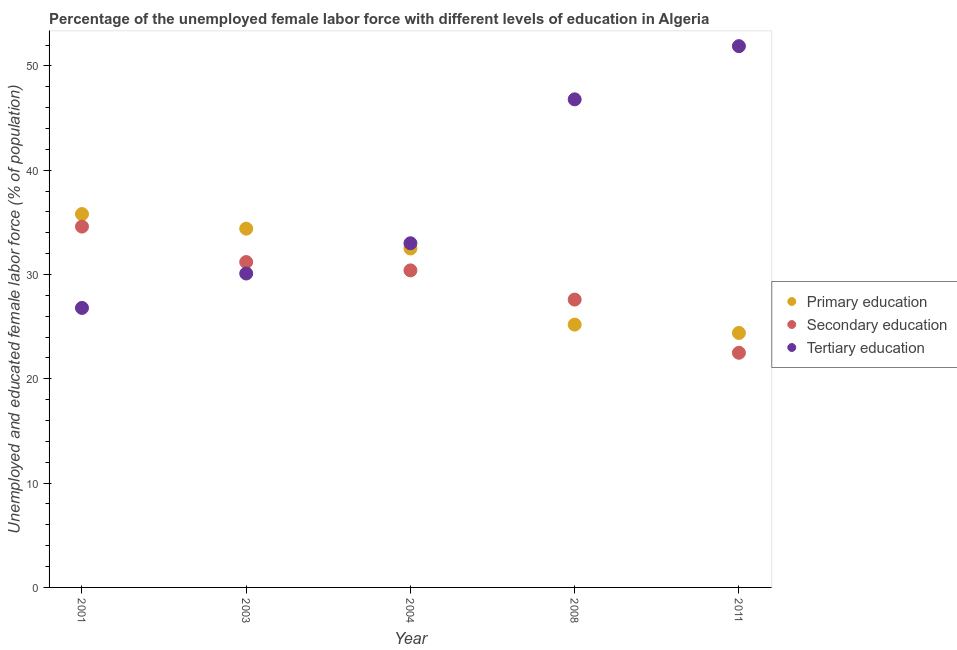How many different coloured dotlines are there?
Give a very brief answer. 3. Is the number of dotlines equal to the number of legend labels?
Your answer should be compact. Yes. What is the percentage of female labor force who received primary education in 2008?
Make the answer very short. 25.2. Across all years, what is the maximum percentage of female labor force who received primary education?
Ensure brevity in your answer.  35.8. Across all years, what is the minimum percentage of female labor force who received primary education?
Your response must be concise. 24.4. What is the total percentage of female labor force who received tertiary education in the graph?
Provide a short and direct response. 188.6. What is the difference between the percentage of female labor force who received tertiary education in 2004 and that in 2011?
Offer a terse response. -18.9. What is the difference between the percentage of female labor force who received tertiary education in 2003 and the percentage of female labor force who received secondary education in 2004?
Keep it short and to the point. -0.3. What is the average percentage of female labor force who received primary education per year?
Offer a very short reply. 30.46. In the year 2003, what is the difference between the percentage of female labor force who received primary education and percentage of female labor force who received tertiary education?
Offer a very short reply. 4.3. What is the ratio of the percentage of female labor force who received primary education in 2003 to that in 2011?
Your answer should be very brief. 1.41. What is the difference between the highest and the second highest percentage of female labor force who received tertiary education?
Keep it short and to the point. 5.1. What is the difference between the highest and the lowest percentage of female labor force who received primary education?
Give a very brief answer. 11.4. In how many years, is the percentage of female labor force who received tertiary education greater than the average percentage of female labor force who received tertiary education taken over all years?
Offer a terse response. 2. Does the percentage of female labor force who received primary education monotonically increase over the years?
Your answer should be compact. No. Is the percentage of female labor force who received primary education strictly less than the percentage of female labor force who received secondary education over the years?
Make the answer very short. No. What is the difference between two consecutive major ticks on the Y-axis?
Provide a short and direct response. 10. Are the values on the major ticks of Y-axis written in scientific E-notation?
Provide a short and direct response. No. Does the graph contain any zero values?
Ensure brevity in your answer.  No. Where does the legend appear in the graph?
Keep it short and to the point. Center right. How are the legend labels stacked?
Give a very brief answer. Vertical. What is the title of the graph?
Offer a very short reply. Percentage of the unemployed female labor force with different levels of education in Algeria. Does "Total employers" appear as one of the legend labels in the graph?
Ensure brevity in your answer.  No. What is the label or title of the X-axis?
Provide a short and direct response. Year. What is the label or title of the Y-axis?
Provide a short and direct response. Unemployed and educated female labor force (% of population). What is the Unemployed and educated female labor force (% of population) in Primary education in 2001?
Ensure brevity in your answer.  35.8. What is the Unemployed and educated female labor force (% of population) in Secondary education in 2001?
Give a very brief answer. 34.6. What is the Unemployed and educated female labor force (% of population) of Tertiary education in 2001?
Offer a very short reply. 26.8. What is the Unemployed and educated female labor force (% of population) of Primary education in 2003?
Provide a succinct answer. 34.4. What is the Unemployed and educated female labor force (% of population) in Secondary education in 2003?
Make the answer very short. 31.2. What is the Unemployed and educated female labor force (% of population) of Tertiary education in 2003?
Ensure brevity in your answer.  30.1. What is the Unemployed and educated female labor force (% of population) of Primary education in 2004?
Make the answer very short. 32.5. What is the Unemployed and educated female labor force (% of population) of Secondary education in 2004?
Offer a very short reply. 30.4. What is the Unemployed and educated female labor force (% of population) of Primary education in 2008?
Offer a very short reply. 25.2. What is the Unemployed and educated female labor force (% of population) of Secondary education in 2008?
Make the answer very short. 27.6. What is the Unemployed and educated female labor force (% of population) in Tertiary education in 2008?
Ensure brevity in your answer.  46.8. What is the Unemployed and educated female labor force (% of population) in Primary education in 2011?
Offer a terse response. 24.4. What is the Unemployed and educated female labor force (% of population) of Secondary education in 2011?
Offer a very short reply. 22.5. What is the Unemployed and educated female labor force (% of population) of Tertiary education in 2011?
Provide a succinct answer. 51.9. Across all years, what is the maximum Unemployed and educated female labor force (% of population) of Primary education?
Your answer should be very brief. 35.8. Across all years, what is the maximum Unemployed and educated female labor force (% of population) of Secondary education?
Your answer should be compact. 34.6. Across all years, what is the maximum Unemployed and educated female labor force (% of population) of Tertiary education?
Give a very brief answer. 51.9. Across all years, what is the minimum Unemployed and educated female labor force (% of population) in Primary education?
Your response must be concise. 24.4. Across all years, what is the minimum Unemployed and educated female labor force (% of population) in Tertiary education?
Your answer should be very brief. 26.8. What is the total Unemployed and educated female labor force (% of population) of Primary education in the graph?
Give a very brief answer. 152.3. What is the total Unemployed and educated female labor force (% of population) in Secondary education in the graph?
Offer a terse response. 146.3. What is the total Unemployed and educated female labor force (% of population) in Tertiary education in the graph?
Offer a terse response. 188.6. What is the difference between the Unemployed and educated female labor force (% of population) in Primary education in 2001 and that in 2003?
Offer a very short reply. 1.4. What is the difference between the Unemployed and educated female labor force (% of population) of Secondary education in 2001 and that in 2003?
Make the answer very short. 3.4. What is the difference between the Unemployed and educated female labor force (% of population) of Primary education in 2001 and that in 2004?
Your response must be concise. 3.3. What is the difference between the Unemployed and educated female labor force (% of population) of Tertiary education in 2001 and that in 2004?
Your response must be concise. -6.2. What is the difference between the Unemployed and educated female labor force (% of population) of Secondary education in 2001 and that in 2011?
Keep it short and to the point. 12.1. What is the difference between the Unemployed and educated female labor force (% of population) in Tertiary education in 2001 and that in 2011?
Make the answer very short. -25.1. What is the difference between the Unemployed and educated female labor force (% of population) in Primary education in 2003 and that in 2008?
Offer a terse response. 9.2. What is the difference between the Unemployed and educated female labor force (% of population) of Secondary education in 2003 and that in 2008?
Provide a short and direct response. 3.6. What is the difference between the Unemployed and educated female labor force (% of population) of Tertiary education in 2003 and that in 2008?
Give a very brief answer. -16.7. What is the difference between the Unemployed and educated female labor force (% of population) of Secondary education in 2003 and that in 2011?
Provide a succinct answer. 8.7. What is the difference between the Unemployed and educated female labor force (% of population) in Tertiary education in 2003 and that in 2011?
Provide a short and direct response. -21.8. What is the difference between the Unemployed and educated female labor force (% of population) of Secondary education in 2004 and that in 2008?
Your response must be concise. 2.8. What is the difference between the Unemployed and educated female labor force (% of population) of Primary education in 2004 and that in 2011?
Provide a succinct answer. 8.1. What is the difference between the Unemployed and educated female labor force (% of population) of Tertiary education in 2004 and that in 2011?
Offer a terse response. -18.9. What is the difference between the Unemployed and educated female labor force (% of population) in Secondary education in 2008 and that in 2011?
Your answer should be compact. 5.1. What is the difference between the Unemployed and educated female labor force (% of population) of Tertiary education in 2008 and that in 2011?
Your answer should be compact. -5.1. What is the difference between the Unemployed and educated female labor force (% of population) of Primary education in 2001 and the Unemployed and educated female labor force (% of population) of Secondary education in 2003?
Your response must be concise. 4.6. What is the difference between the Unemployed and educated female labor force (% of population) in Primary education in 2001 and the Unemployed and educated female labor force (% of population) in Tertiary education in 2003?
Make the answer very short. 5.7. What is the difference between the Unemployed and educated female labor force (% of population) of Primary education in 2001 and the Unemployed and educated female labor force (% of population) of Secondary education in 2004?
Make the answer very short. 5.4. What is the difference between the Unemployed and educated female labor force (% of population) in Primary education in 2001 and the Unemployed and educated female labor force (% of population) in Tertiary education in 2004?
Provide a short and direct response. 2.8. What is the difference between the Unemployed and educated female labor force (% of population) in Secondary education in 2001 and the Unemployed and educated female labor force (% of population) in Tertiary education in 2004?
Your answer should be very brief. 1.6. What is the difference between the Unemployed and educated female labor force (% of population) in Secondary education in 2001 and the Unemployed and educated female labor force (% of population) in Tertiary education in 2008?
Offer a terse response. -12.2. What is the difference between the Unemployed and educated female labor force (% of population) in Primary education in 2001 and the Unemployed and educated female labor force (% of population) in Secondary education in 2011?
Keep it short and to the point. 13.3. What is the difference between the Unemployed and educated female labor force (% of population) of Primary education in 2001 and the Unemployed and educated female labor force (% of population) of Tertiary education in 2011?
Your answer should be very brief. -16.1. What is the difference between the Unemployed and educated female labor force (% of population) of Secondary education in 2001 and the Unemployed and educated female labor force (% of population) of Tertiary education in 2011?
Provide a short and direct response. -17.3. What is the difference between the Unemployed and educated female labor force (% of population) of Secondary education in 2003 and the Unemployed and educated female labor force (% of population) of Tertiary education in 2004?
Offer a very short reply. -1.8. What is the difference between the Unemployed and educated female labor force (% of population) in Primary education in 2003 and the Unemployed and educated female labor force (% of population) in Tertiary education in 2008?
Make the answer very short. -12.4. What is the difference between the Unemployed and educated female labor force (% of population) in Secondary education in 2003 and the Unemployed and educated female labor force (% of population) in Tertiary education in 2008?
Your answer should be compact. -15.6. What is the difference between the Unemployed and educated female labor force (% of population) in Primary education in 2003 and the Unemployed and educated female labor force (% of population) in Secondary education in 2011?
Give a very brief answer. 11.9. What is the difference between the Unemployed and educated female labor force (% of population) of Primary education in 2003 and the Unemployed and educated female labor force (% of population) of Tertiary education in 2011?
Ensure brevity in your answer.  -17.5. What is the difference between the Unemployed and educated female labor force (% of population) of Secondary education in 2003 and the Unemployed and educated female labor force (% of population) of Tertiary education in 2011?
Offer a very short reply. -20.7. What is the difference between the Unemployed and educated female labor force (% of population) in Primary education in 2004 and the Unemployed and educated female labor force (% of population) in Tertiary education in 2008?
Offer a very short reply. -14.3. What is the difference between the Unemployed and educated female labor force (% of population) in Secondary education in 2004 and the Unemployed and educated female labor force (% of population) in Tertiary education in 2008?
Offer a very short reply. -16.4. What is the difference between the Unemployed and educated female labor force (% of population) in Primary education in 2004 and the Unemployed and educated female labor force (% of population) in Secondary education in 2011?
Your answer should be compact. 10. What is the difference between the Unemployed and educated female labor force (% of population) in Primary education in 2004 and the Unemployed and educated female labor force (% of population) in Tertiary education in 2011?
Your answer should be very brief. -19.4. What is the difference between the Unemployed and educated female labor force (% of population) of Secondary education in 2004 and the Unemployed and educated female labor force (% of population) of Tertiary education in 2011?
Provide a succinct answer. -21.5. What is the difference between the Unemployed and educated female labor force (% of population) of Primary education in 2008 and the Unemployed and educated female labor force (% of population) of Tertiary education in 2011?
Provide a succinct answer. -26.7. What is the difference between the Unemployed and educated female labor force (% of population) of Secondary education in 2008 and the Unemployed and educated female labor force (% of population) of Tertiary education in 2011?
Ensure brevity in your answer.  -24.3. What is the average Unemployed and educated female labor force (% of population) of Primary education per year?
Your response must be concise. 30.46. What is the average Unemployed and educated female labor force (% of population) in Secondary education per year?
Make the answer very short. 29.26. What is the average Unemployed and educated female labor force (% of population) of Tertiary education per year?
Make the answer very short. 37.72. In the year 2001, what is the difference between the Unemployed and educated female labor force (% of population) in Primary education and Unemployed and educated female labor force (% of population) in Secondary education?
Offer a very short reply. 1.2. In the year 2001, what is the difference between the Unemployed and educated female labor force (% of population) in Primary education and Unemployed and educated female labor force (% of population) in Tertiary education?
Ensure brevity in your answer.  9. In the year 2001, what is the difference between the Unemployed and educated female labor force (% of population) of Secondary education and Unemployed and educated female labor force (% of population) of Tertiary education?
Your answer should be very brief. 7.8. In the year 2003, what is the difference between the Unemployed and educated female labor force (% of population) in Primary education and Unemployed and educated female labor force (% of population) in Tertiary education?
Your answer should be very brief. 4.3. In the year 2003, what is the difference between the Unemployed and educated female labor force (% of population) in Secondary education and Unemployed and educated female labor force (% of population) in Tertiary education?
Your answer should be compact. 1.1. In the year 2004, what is the difference between the Unemployed and educated female labor force (% of population) of Primary education and Unemployed and educated female labor force (% of population) of Tertiary education?
Offer a terse response. -0.5. In the year 2004, what is the difference between the Unemployed and educated female labor force (% of population) in Secondary education and Unemployed and educated female labor force (% of population) in Tertiary education?
Your answer should be compact. -2.6. In the year 2008, what is the difference between the Unemployed and educated female labor force (% of population) in Primary education and Unemployed and educated female labor force (% of population) in Secondary education?
Provide a succinct answer. -2.4. In the year 2008, what is the difference between the Unemployed and educated female labor force (% of population) of Primary education and Unemployed and educated female labor force (% of population) of Tertiary education?
Keep it short and to the point. -21.6. In the year 2008, what is the difference between the Unemployed and educated female labor force (% of population) in Secondary education and Unemployed and educated female labor force (% of population) in Tertiary education?
Make the answer very short. -19.2. In the year 2011, what is the difference between the Unemployed and educated female labor force (% of population) of Primary education and Unemployed and educated female labor force (% of population) of Secondary education?
Your answer should be very brief. 1.9. In the year 2011, what is the difference between the Unemployed and educated female labor force (% of population) in Primary education and Unemployed and educated female labor force (% of population) in Tertiary education?
Provide a short and direct response. -27.5. In the year 2011, what is the difference between the Unemployed and educated female labor force (% of population) in Secondary education and Unemployed and educated female labor force (% of population) in Tertiary education?
Give a very brief answer. -29.4. What is the ratio of the Unemployed and educated female labor force (% of population) in Primary education in 2001 to that in 2003?
Your response must be concise. 1.04. What is the ratio of the Unemployed and educated female labor force (% of population) in Secondary education in 2001 to that in 2003?
Provide a succinct answer. 1.11. What is the ratio of the Unemployed and educated female labor force (% of population) in Tertiary education in 2001 to that in 2003?
Keep it short and to the point. 0.89. What is the ratio of the Unemployed and educated female labor force (% of population) of Primary education in 2001 to that in 2004?
Give a very brief answer. 1.1. What is the ratio of the Unemployed and educated female labor force (% of population) of Secondary education in 2001 to that in 2004?
Offer a terse response. 1.14. What is the ratio of the Unemployed and educated female labor force (% of population) in Tertiary education in 2001 to that in 2004?
Offer a very short reply. 0.81. What is the ratio of the Unemployed and educated female labor force (% of population) in Primary education in 2001 to that in 2008?
Keep it short and to the point. 1.42. What is the ratio of the Unemployed and educated female labor force (% of population) of Secondary education in 2001 to that in 2008?
Offer a terse response. 1.25. What is the ratio of the Unemployed and educated female labor force (% of population) in Tertiary education in 2001 to that in 2008?
Ensure brevity in your answer.  0.57. What is the ratio of the Unemployed and educated female labor force (% of population) of Primary education in 2001 to that in 2011?
Provide a succinct answer. 1.47. What is the ratio of the Unemployed and educated female labor force (% of population) of Secondary education in 2001 to that in 2011?
Your response must be concise. 1.54. What is the ratio of the Unemployed and educated female labor force (% of population) in Tertiary education in 2001 to that in 2011?
Keep it short and to the point. 0.52. What is the ratio of the Unemployed and educated female labor force (% of population) in Primary education in 2003 to that in 2004?
Your answer should be compact. 1.06. What is the ratio of the Unemployed and educated female labor force (% of population) of Secondary education in 2003 to that in 2004?
Ensure brevity in your answer.  1.03. What is the ratio of the Unemployed and educated female labor force (% of population) of Tertiary education in 2003 to that in 2004?
Provide a short and direct response. 0.91. What is the ratio of the Unemployed and educated female labor force (% of population) in Primary education in 2003 to that in 2008?
Your response must be concise. 1.37. What is the ratio of the Unemployed and educated female labor force (% of population) of Secondary education in 2003 to that in 2008?
Provide a succinct answer. 1.13. What is the ratio of the Unemployed and educated female labor force (% of population) of Tertiary education in 2003 to that in 2008?
Your response must be concise. 0.64. What is the ratio of the Unemployed and educated female labor force (% of population) in Primary education in 2003 to that in 2011?
Your response must be concise. 1.41. What is the ratio of the Unemployed and educated female labor force (% of population) of Secondary education in 2003 to that in 2011?
Provide a short and direct response. 1.39. What is the ratio of the Unemployed and educated female labor force (% of population) in Tertiary education in 2003 to that in 2011?
Offer a terse response. 0.58. What is the ratio of the Unemployed and educated female labor force (% of population) of Primary education in 2004 to that in 2008?
Provide a short and direct response. 1.29. What is the ratio of the Unemployed and educated female labor force (% of population) of Secondary education in 2004 to that in 2008?
Your answer should be very brief. 1.1. What is the ratio of the Unemployed and educated female labor force (% of population) in Tertiary education in 2004 to that in 2008?
Keep it short and to the point. 0.71. What is the ratio of the Unemployed and educated female labor force (% of population) of Primary education in 2004 to that in 2011?
Offer a terse response. 1.33. What is the ratio of the Unemployed and educated female labor force (% of population) of Secondary education in 2004 to that in 2011?
Provide a short and direct response. 1.35. What is the ratio of the Unemployed and educated female labor force (% of population) of Tertiary education in 2004 to that in 2011?
Make the answer very short. 0.64. What is the ratio of the Unemployed and educated female labor force (% of population) in Primary education in 2008 to that in 2011?
Ensure brevity in your answer.  1.03. What is the ratio of the Unemployed and educated female labor force (% of population) in Secondary education in 2008 to that in 2011?
Provide a short and direct response. 1.23. What is the ratio of the Unemployed and educated female labor force (% of population) in Tertiary education in 2008 to that in 2011?
Provide a short and direct response. 0.9. What is the difference between the highest and the second highest Unemployed and educated female labor force (% of population) in Tertiary education?
Your response must be concise. 5.1. What is the difference between the highest and the lowest Unemployed and educated female labor force (% of population) in Primary education?
Ensure brevity in your answer.  11.4. What is the difference between the highest and the lowest Unemployed and educated female labor force (% of population) of Tertiary education?
Offer a terse response. 25.1. 